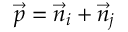<formula> <loc_0><loc_0><loc_500><loc_500>\vec { p } = \vec { n } _ { i } + \vec { n } _ { j }</formula> 